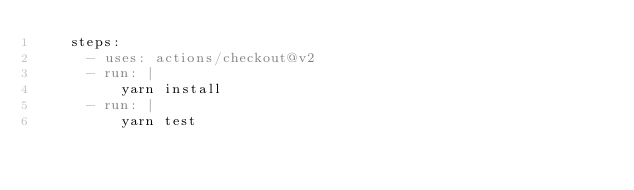<code> <loc_0><loc_0><loc_500><loc_500><_YAML_>    steps:
      - uses: actions/checkout@v2
      - run: |
          yarn install
      - run: |
          yarn test
</code> 